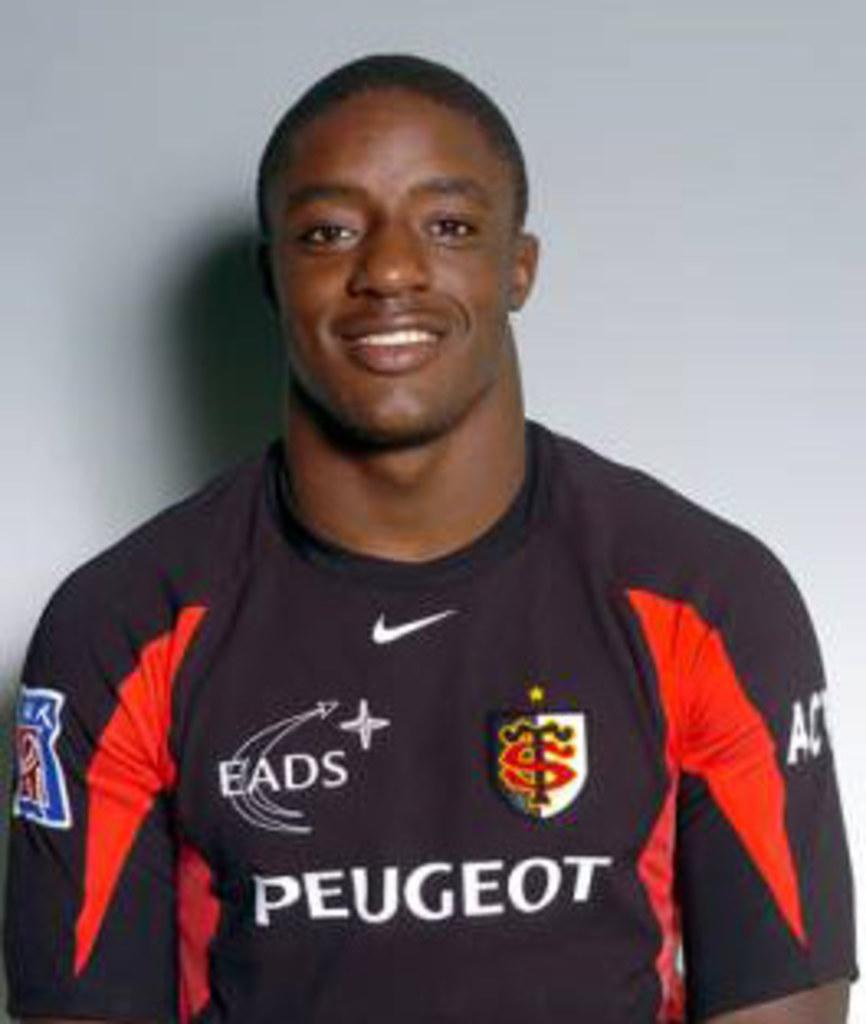<image>
Offer a succinct explanation of the picture presented. A man wearing a shirt that says Peugeot in the center and logos surrounding 